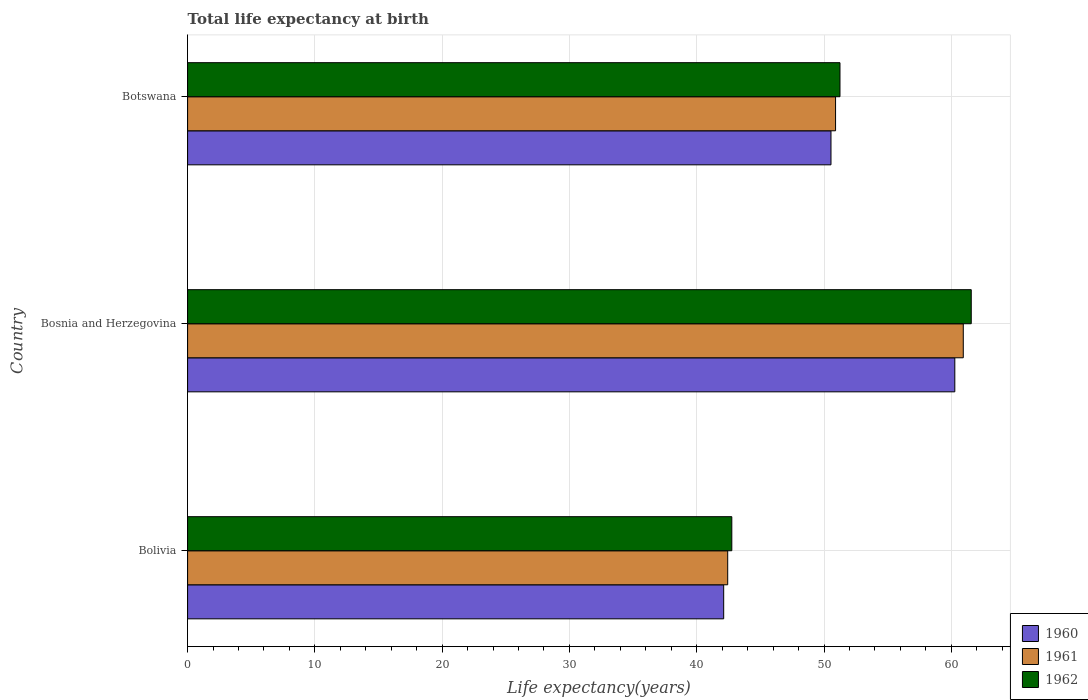How many different coloured bars are there?
Keep it short and to the point. 3. How many groups of bars are there?
Your answer should be compact. 3. Are the number of bars per tick equal to the number of legend labels?
Give a very brief answer. Yes. Are the number of bars on each tick of the Y-axis equal?
Your response must be concise. Yes. How many bars are there on the 2nd tick from the top?
Offer a terse response. 3. What is the label of the 2nd group of bars from the top?
Your answer should be compact. Bosnia and Herzegovina. In how many cases, is the number of bars for a given country not equal to the number of legend labels?
Give a very brief answer. 0. What is the life expectancy at birth in in 1960 in Bolivia?
Your response must be concise. 42.12. Across all countries, what is the maximum life expectancy at birth in in 1960?
Your response must be concise. 60.28. Across all countries, what is the minimum life expectancy at birth in in 1961?
Ensure brevity in your answer.  42.43. In which country was the life expectancy at birth in in 1961 maximum?
Offer a terse response. Bosnia and Herzegovina. In which country was the life expectancy at birth in in 1961 minimum?
Your answer should be very brief. Bolivia. What is the total life expectancy at birth in in 1961 in the graph?
Your answer should be compact. 154.28. What is the difference between the life expectancy at birth in in 1960 in Bosnia and Herzegovina and that in Botswana?
Your answer should be very brief. 9.73. What is the difference between the life expectancy at birth in in 1960 in Bolivia and the life expectancy at birth in in 1962 in Bosnia and Herzegovina?
Make the answer very short. -19.45. What is the average life expectancy at birth in in 1960 per country?
Give a very brief answer. 50.98. What is the difference between the life expectancy at birth in in 1960 and life expectancy at birth in in 1961 in Bolivia?
Offer a very short reply. -0.32. In how many countries, is the life expectancy at birth in in 1960 greater than 44 years?
Give a very brief answer. 2. What is the ratio of the life expectancy at birth in in 1960 in Bosnia and Herzegovina to that in Botswana?
Keep it short and to the point. 1.19. What is the difference between the highest and the second highest life expectancy at birth in in 1960?
Offer a terse response. 9.73. What is the difference between the highest and the lowest life expectancy at birth in in 1961?
Offer a terse response. 18.51. In how many countries, is the life expectancy at birth in in 1962 greater than the average life expectancy at birth in in 1962 taken over all countries?
Offer a very short reply. 1. Is the sum of the life expectancy at birth in in 1962 in Bosnia and Herzegovina and Botswana greater than the maximum life expectancy at birth in in 1961 across all countries?
Provide a succinct answer. Yes. What does the 3rd bar from the top in Bolivia represents?
Make the answer very short. 1960. How many bars are there?
Provide a succinct answer. 9. Are all the bars in the graph horizontal?
Ensure brevity in your answer.  Yes. How many countries are there in the graph?
Give a very brief answer. 3. What is the difference between two consecutive major ticks on the X-axis?
Your response must be concise. 10. Does the graph contain grids?
Provide a short and direct response. Yes. How many legend labels are there?
Keep it short and to the point. 3. How are the legend labels stacked?
Your answer should be compact. Vertical. What is the title of the graph?
Make the answer very short. Total life expectancy at birth. Does "1982" appear as one of the legend labels in the graph?
Make the answer very short. No. What is the label or title of the X-axis?
Ensure brevity in your answer.  Life expectancy(years). What is the label or title of the Y-axis?
Your answer should be compact. Country. What is the Life expectancy(years) of 1960 in Bolivia?
Your answer should be compact. 42.12. What is the Life expectancy(years) of 1961 in Bolivia?
Your answer should be compact. 42.43. What is the Life expectancy(years) in 1962 in Bolivia?
Give a very brief answer. 42.76. What is the Life expectancy(years) of 1960 in Bosnia and Herzegovina?
Offer a terse response. 60.28. What is the Life expectancy(years) in 1961 in Bosnia and Herzegovina?
Make the answer very short. 60.94. What is the Life expectancy(years) in 1962 in Bosnia and Herzegovina?
Give a very brief answer. 61.57. What is the Life expectancy(years) in 1960 in Botswana?
Offer a very short reply. 50.55. What is the Life expectancy(years) in 1961 in Botswana?
Keep it short and to the point. 50.91. What is the Life expectancy(years) in 1962 in Botswana?
Provide a short and direct response. 51.26. Across all countries, what is the maximum Life expectancy(years) in 1960?
Provide a succinct answer. 60.28. Across all countries, what is the maximum Life expectancy(years) in 1961?
Keep it short and to the point. 60.94. Across all countries, what is the maximum Life expectancy(years) in 1962?
Your answer should be compact. 61.57. Across all countries, what is the minimum Life expectancy(years) of 1960?
Offer a terse response. 42.12. Across all countries, what is the minimum Life expectancy(years) of 1961?
Offer a terse response. 42.43. Across all countries, what is the minimum Life expectancy(years) of 1962?
Your response must be concise. 42.76. What is the total Life expectancy(years) in 1960 in the graph?
Offer a terse response. 152.94. What is the total Life expectancy(years) in 1961 in the graph?
Keep it short and to the point. 154.28. What is the total Life expectancy(years) of 1962 in the graph?
Offer a very short reply. 155.58. What is the difference between the Life expectancy(years) of 1960 in Bolivia and that in Bosnia and Herzegovina?
Ensure brevity in your answer.  -18.16. What is the difference between the Life expectancy(years) of 1961 in Bolivia and that in Bosnia and Herzegovina?
Offer a very short reply. -18.51. What is the difference between the Life expectancy(years) in 1962 in Bolivia and that in Bosnia and Herzegovina?
Your answer should be compact. -18.81. What is the difference between the Life expectancy(years) of 1960 in Bolivia and that in Botswana?
Provide a short and direct response. -8.43. What is the difference between the Life expectancy(years) of 1961 in Bolivia and that in Botswana?
Your response must be concise. -8.47. What is the difference between the Life expectancy(years) in 1962 in Bolivia and that in Botswana?
Ensure brevity in your answer.  -8.5. What is the difference between the Life expectancy(years) in 1960 in Bosnia and Herzegovina and that in Botswana?
Your answer should be very brief. 9.73. What is the difference between the Life expectancy(years) of 1961 in Bosnia and Herzegovina and that in Botswana?
Provide a short and direct response. 10.03. What is the difference between the Life expectancy(years) in 1962 in Bosnia and Herzegovina and that in Botswana?
Provide a succinct answer. 10.31. What is the difference between the Life expectancy(years) in 1960 in Bolivia and the Life expectancy(years) in 1961 in Bosnia and Herzegovina?
Provide a succinct answer. -18.82. What is the difference between the Life expectancy(years) in 1960 in Bolivia and the Life expectancy(years) in 1962 in Bosnia and Herzegovina?
Your answer should be compact. -19.45. What is the difference between the Life expectancy(years) of 1961 in Bolivia and the Life expectancy(years) of 1962 in Bosnia and Herzegovina?
Provide a succinct answer. -19.13. What is the difference between the Life expectancy(years) in 1960 in Bolivia and the Life expectancy(years) in 1961 in Botswana?
Your answer should be compact. -8.79. What is the difference between the Life expectancy(years) of 1960 in Bolivia and the Life expectancy(years) of 1962 in Botswana?
Make the answer very short. -9.14. What is the difference between the Life expectancy(years) in 1961 in Bolivia and the Life expectancy(years) in 1962 in Botswana?
Make the answer very short. -8.82. What is the difference between the Life expectancy(years) of 1960 in Bosnia and Herzegovina and the Life expectancy(years) of 1961 in Botswana?
Your answer should be compact. 9.37. What is the difference between the Life expectancy(years) in 1960 in Bosnia and Herzegovina and the Life expectancy(years) in 1962 in Botswana?
Give a very brief answer. 9.02. What is the difference between the Life expectancy(years) of 1961 in Bosnia and Herzegovina and the Life expectancy(years) of 1962 in Botswana?
Your answer should be compact. 9.69. What is the average Life expectancy(years) in 1960 per country?
Your answer should be very brief. 50.98. What is the average Life expectancy(years) in 1961 per country?
Give a very brief answer. 51.43. What is the average Life expectancy(years) in 1962 per country?
Provide a short and direct response. 51.86. What is the difference between the Life expectancy(years) of 1960 and Life expectancy(years) of 1961 in Bolivia?
Your response must be concise. -0.32. What is the difference between the Life expectancy(years) in 1960 and Life expectancy(years) in 1962 in Bolivia?
Offer a very short reply. -0.64. What is the difference between the Life expectancy(years) of 1961 and Life expectancy(years) of 1962 in Bolivia?
Your answer should be compact. -0.32. What is the difference between the Life expectancy(years) in 1960 and Life expectancy(years) in 1961 in Bosnia and Herzegovina?
Offer a very short reply. -0.67. What is the difference between the Life expectancy(years) of 1960 and Life expectancy(years) of 1962 in Bosnia and Herzegovina?
Give a very brief answer. -1.29. What is the difference between the Life expectancy(years) in 1961 and Life expectancy(years) in 1962 in Bosnia and Herzegovina?
Make the answer very short. -0.63. What is the difference between the Life expectancy(years) of 1960 and Life expectancy(years) of 1961 in Botswana?
Keep it short and to the point. -0.36. What is the difference between the Life expectancy(years) in 1960 and Life expectancy(years) in 1962 in Botswana?
Provide a succinct answer. -0.71. What is the difference between the Life expectancy(years) in 1961 and Life expectancy(years) in 1962 in Botswana?
Your response must be concise. -0.35. What is the ratio of the Life expectancy(years) of 1960 in Bolivia to that in Bosnia and Herzegovina?
Keep it short and to the point. 0.7. What is the ratio of the Life expectancy(years) in 1961 in Bolivia to that in Bosnia and Herzegovina?
Provide a short and direct response. 0.7. What is the ratio of the Life expectancy(years) in 1962 in Bolivia to that in Bosnia and Herzegovina?
Provide a succinct answer. 0.69. What is the ratio of the Life expectancy(years) in 1960 in Bolivia to that in Botswana?
Make the answer very short. 0.83. What is the ratio of the Life expectancy(years) of 1961 in Bolivia to that in Botswana?
Your answer should be compact. 0.83. What is the ratio of the Life expectancy(years) in 1962 in Bolivia to that in Botswana?
Give a very brief answer. 0.83. What is the ratio of the Life expectancy(years) in 1960 in Bosnia and Herzegovina to that in Botswana?
Offer a very short reply. 1.19. What is the ratio of the Life expectancy(years) of 1961 in Bosnia and Herzegovina to that in Botswana?
Make the answer very short. 1.2. What is the ratio of the Life expectancy(years) in 1962 in Bosnia and Herzegovina to that in Botswana?
Give a very brief answer. 1.2. What is the difference between the highest and the second highest Life expectancy(years) of 1960?
Your answer should be compact. 9.73. What is the difference between the highest and the second highest Life expectancy(years) in 1961?
Give a very brief answer. 10.03. What is the difference between the highest and the second highest Life expectancy(years) of 1962?
Provide a succinct answer. 10.31. What is the difference between the highest and the lowest Life expectancy(years) of 1960?
Ensure brevity in your answer.  18.16. What is the difference between the highest and the lowest Life expectancy(years) of 1961?
Your answer should be compact. 18.51. What is the difference between the highest and the lowest Life expectancy(years) in 1962?
Your response must be concise. 18.81. 